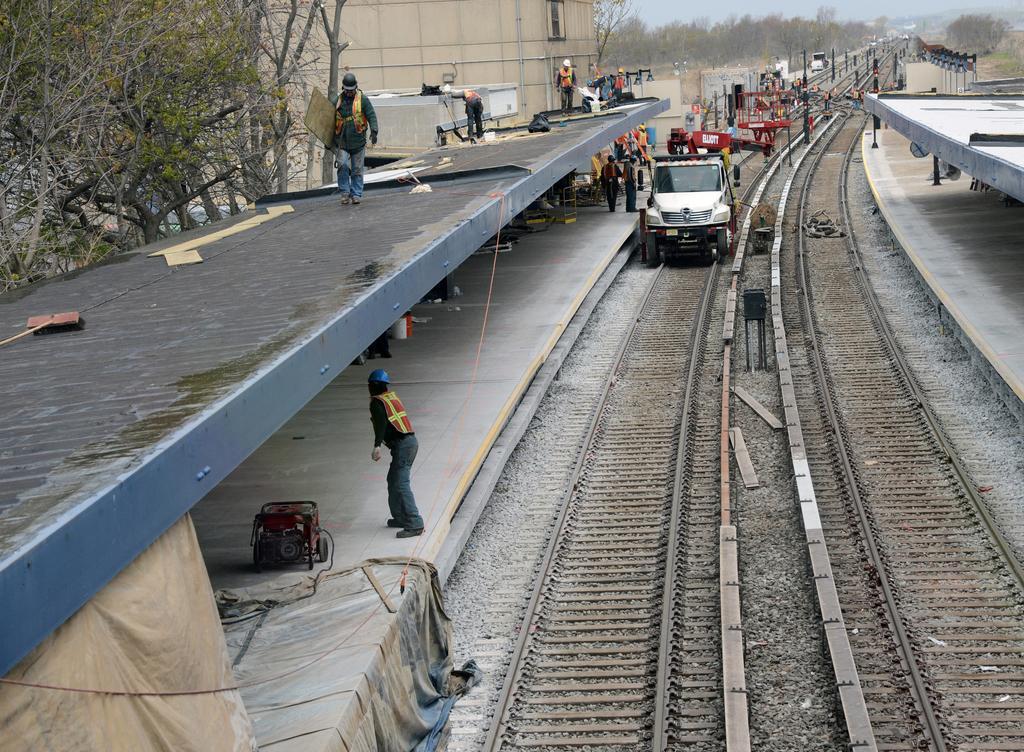In one or two sentences, can you explain what this image depicts? This is the picture of a vehicle on the train track and around there are some people, trees and some cloth on the floor. 